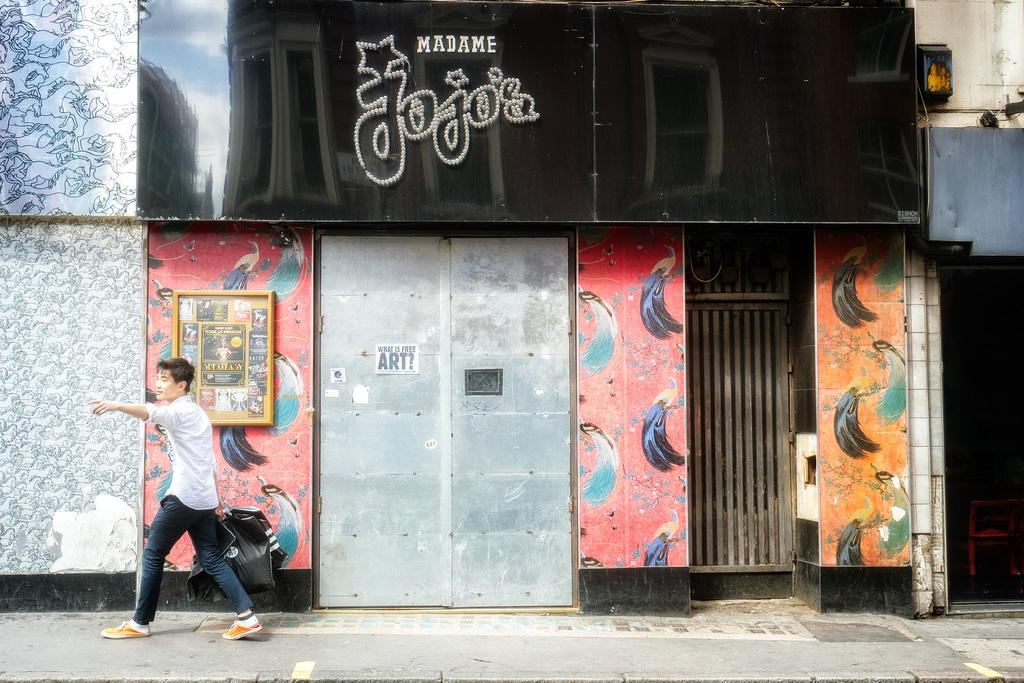Who is present in the image? There is a person in the image. What is the person holding? The person is holding covers. What is the setting of the image? The person is walking in front of buildings. What type of walls can be seen in the image? There are painted walls visible. What is written or displayed on the board in the image? There is a board with text in the image. What type of destruction can be seen in the image? There is no destruction present in the image. How many birds are in the flock that is visible in the image? There is no flock of birds present in the image. 